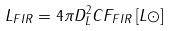<formula> <loc_0><loc_0><loc_500><loc_500>L _ { F I R } = 4 \pi D _ { L } ^ { 2 } C F _ { F I R } \left [ L \odot \right ]</formula> 